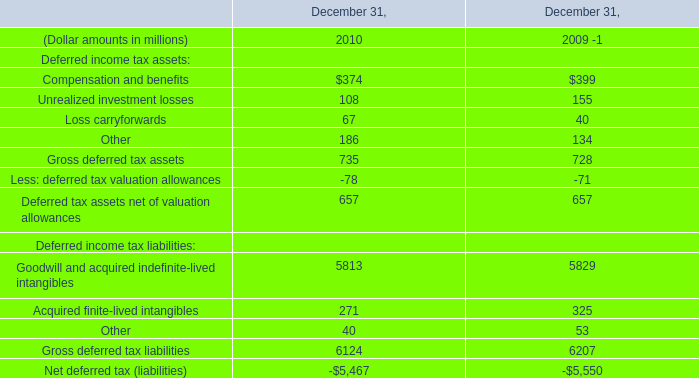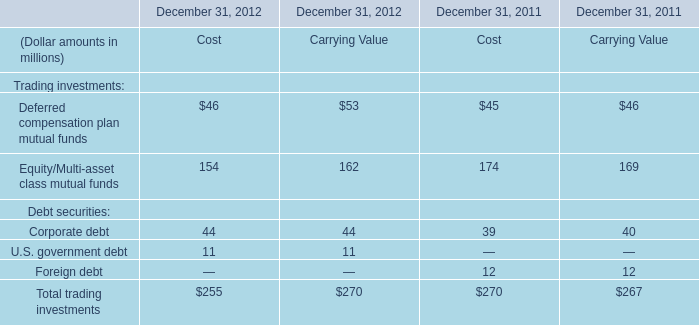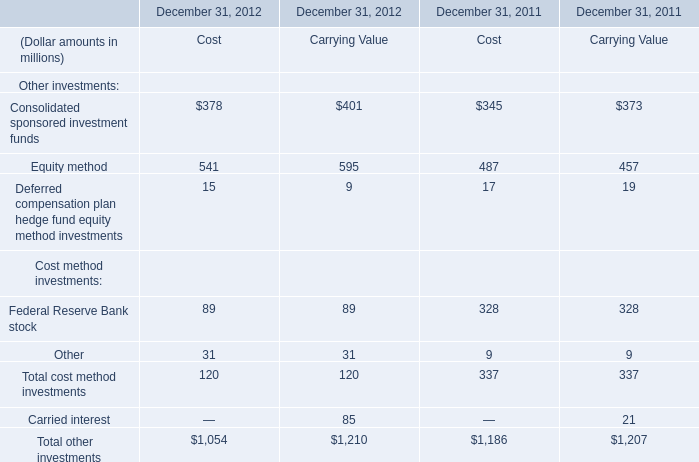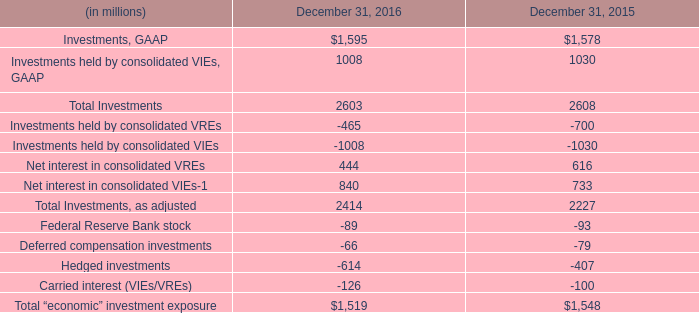What will Corporate debt be like in 2013 if it continues to grow at the same rate as it did in 2012? (in million) 
Computations: ((1 + ((255 - 270) / 270)) * 255)
Answer: 240.83333. 